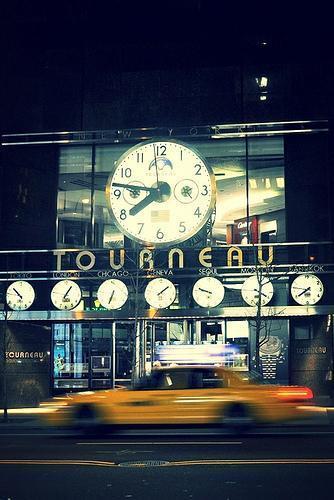How many cars are in the photo?
Give a very brief answer. 1. How many clocks?
Give a very brief answer. 7. 